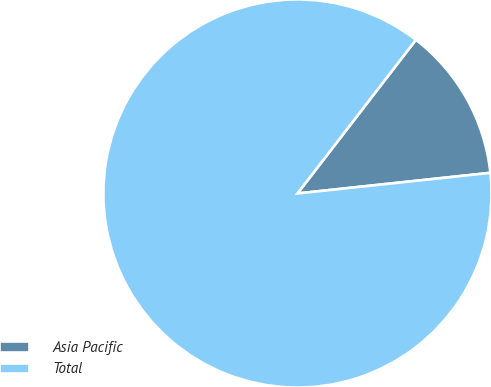Convert chart to OTSL. <chart><loc_0><loc_0><loc_500><loc_500><pie_chart><fcel>Asia Pacific<fcel>Total<nl><fcel>12.85%<fcel>87.15%<nl></chart> 